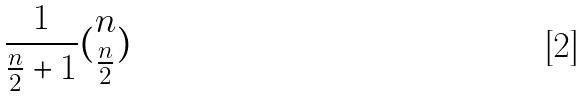Convert formula to latex. <formula><loc_0><loc_0><loc_500><loc_500>\frac { 1 } { \frac { n } { 2 } + 1 } ( \begin{matrix} n \\ \frac { n } { 2 } \end{matrix} )</formula> 